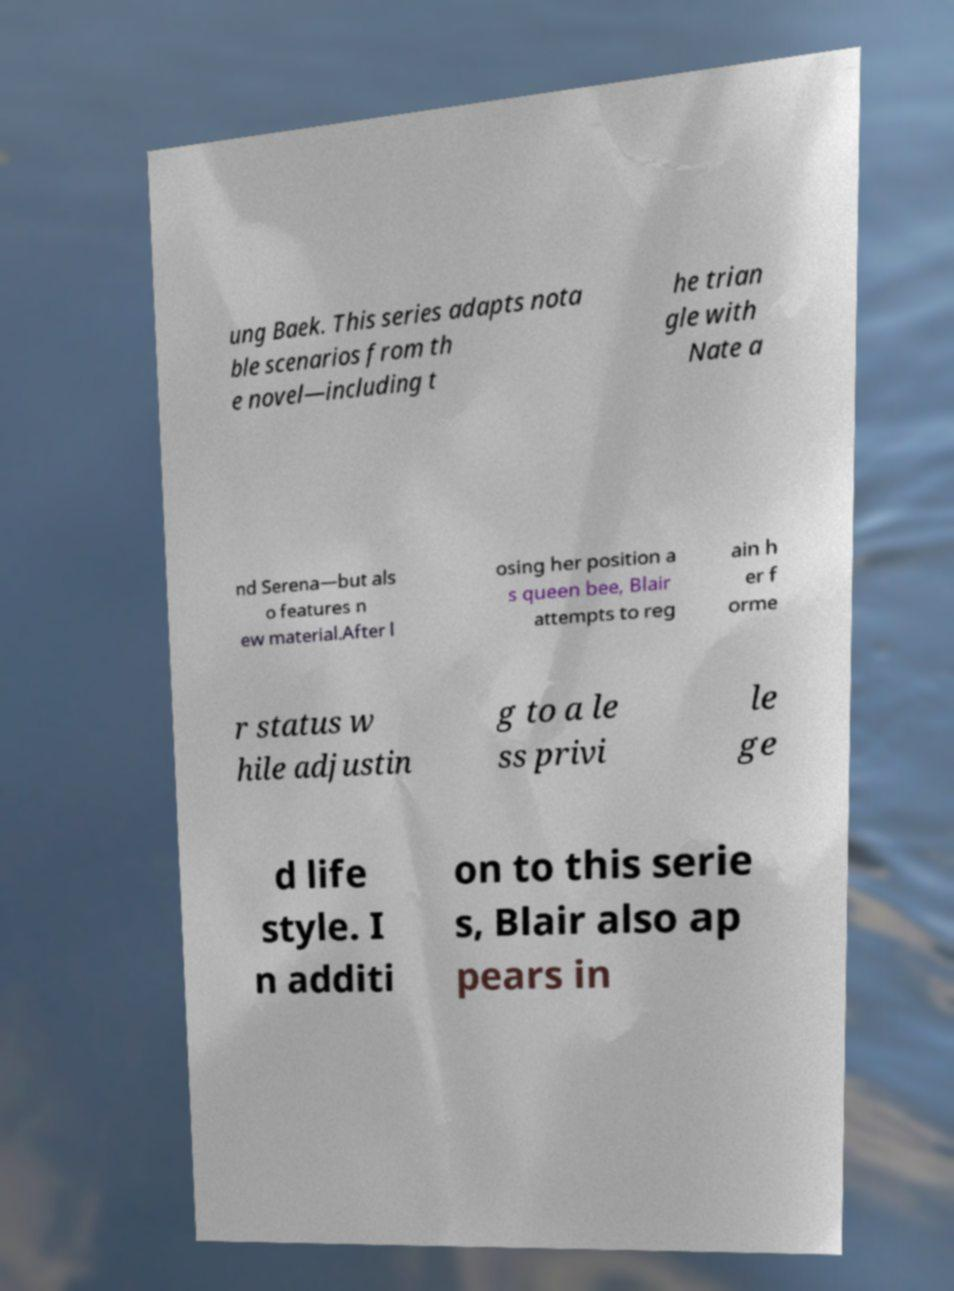I need the written content from this picture converted into text. Can you do that? ung Baek. This series adapts nota ble scenarios from th e novel—including t he trian gle with Nate a nd Serena—but als o features n ew material.After l osing her position a s queen bee, Blair attempts to reg ain h er f orme r status w hile adjustin g to a le ss privi le ge d life style. I n additi on to this serie s, Blair also ap pears in 